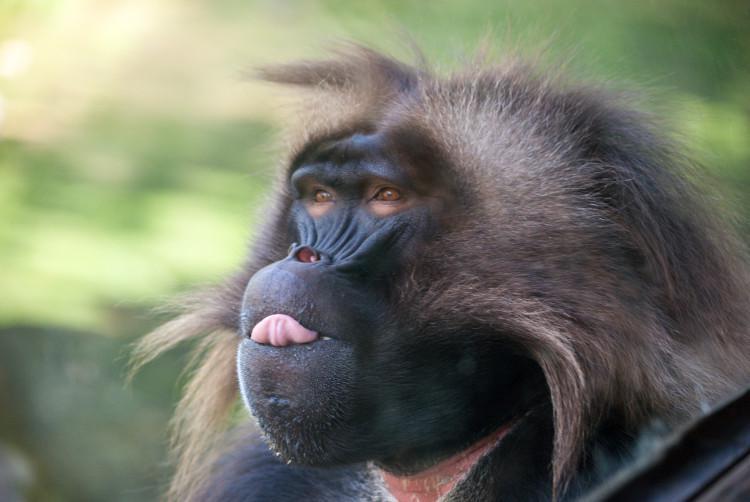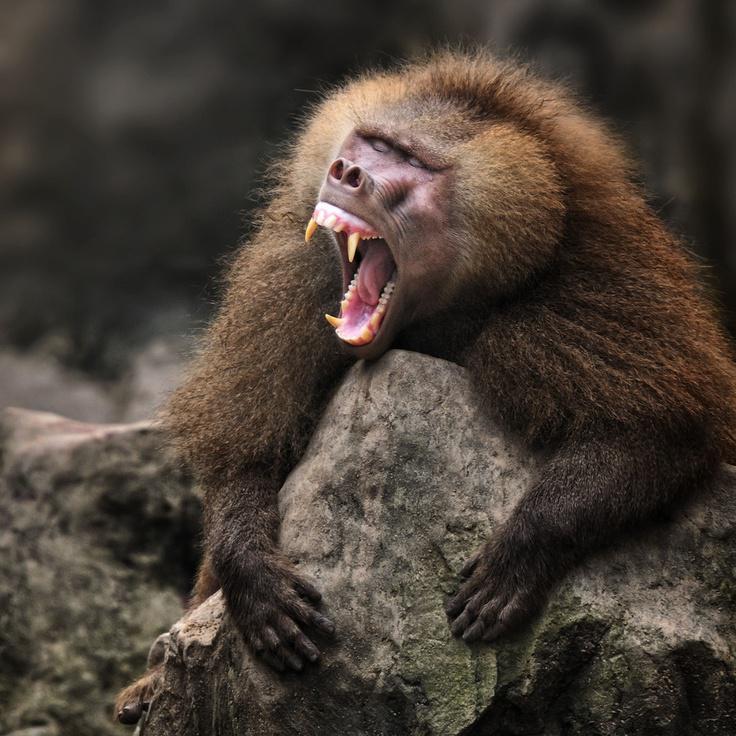The first image is the image on the left, the second image is the image on the right. Assess this claim about the two images: "There is exactly one animal baring its teeth in the image on the right.". Correct or not? Answer yes or no. Yes. 